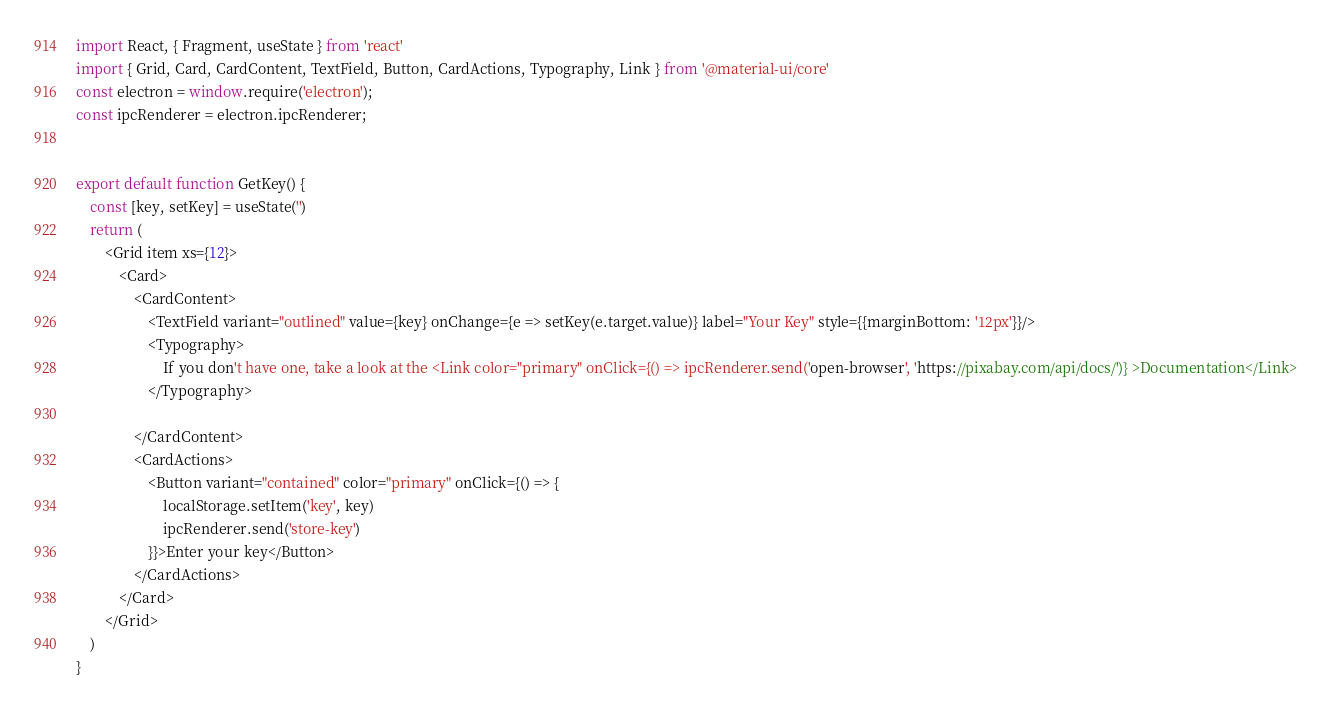<code> <loc_0><loc_0><loc_500><loc_500><_JavaScript_>import React, { Fragment, useState } from 'react'
import { Grid, Card, CardContent, TextField, Button, CardActions, Typography, Link } from '@material-ui/core'
const electron = window.require('electron');
const ipcRenderer = electron.ipcRenderer;


export default function GetKey() {
    const [key, setKey] = useState('')
    return (
        <Grid item xs={12}>
            <Card>
                <CardContent>
                    <TextField variant="outlined" value={key} onChange={e => setKey(e.target.value)} label="Your Key" style={{marginBottom: '12px'}}/>
                    <Typography>
                        If you don't have one, take a look at the <Link color="primary" onClick={() => ipcRenderer.send('open-browser', 'https://pixabay.com/api/docs/')} >Documentation</Link>
                    </Typography>

                </CardContent>
                <CardActions>
                    <Button variant="contained" color="primary" onClick={() => {
                        localStorage.setItem('key', key)
                        ipcRenderer.send('store-key')
                    }}>Enter your key</Button>
                </CardActions>
            </Card>
        </Grid>
    )
}
</code> 